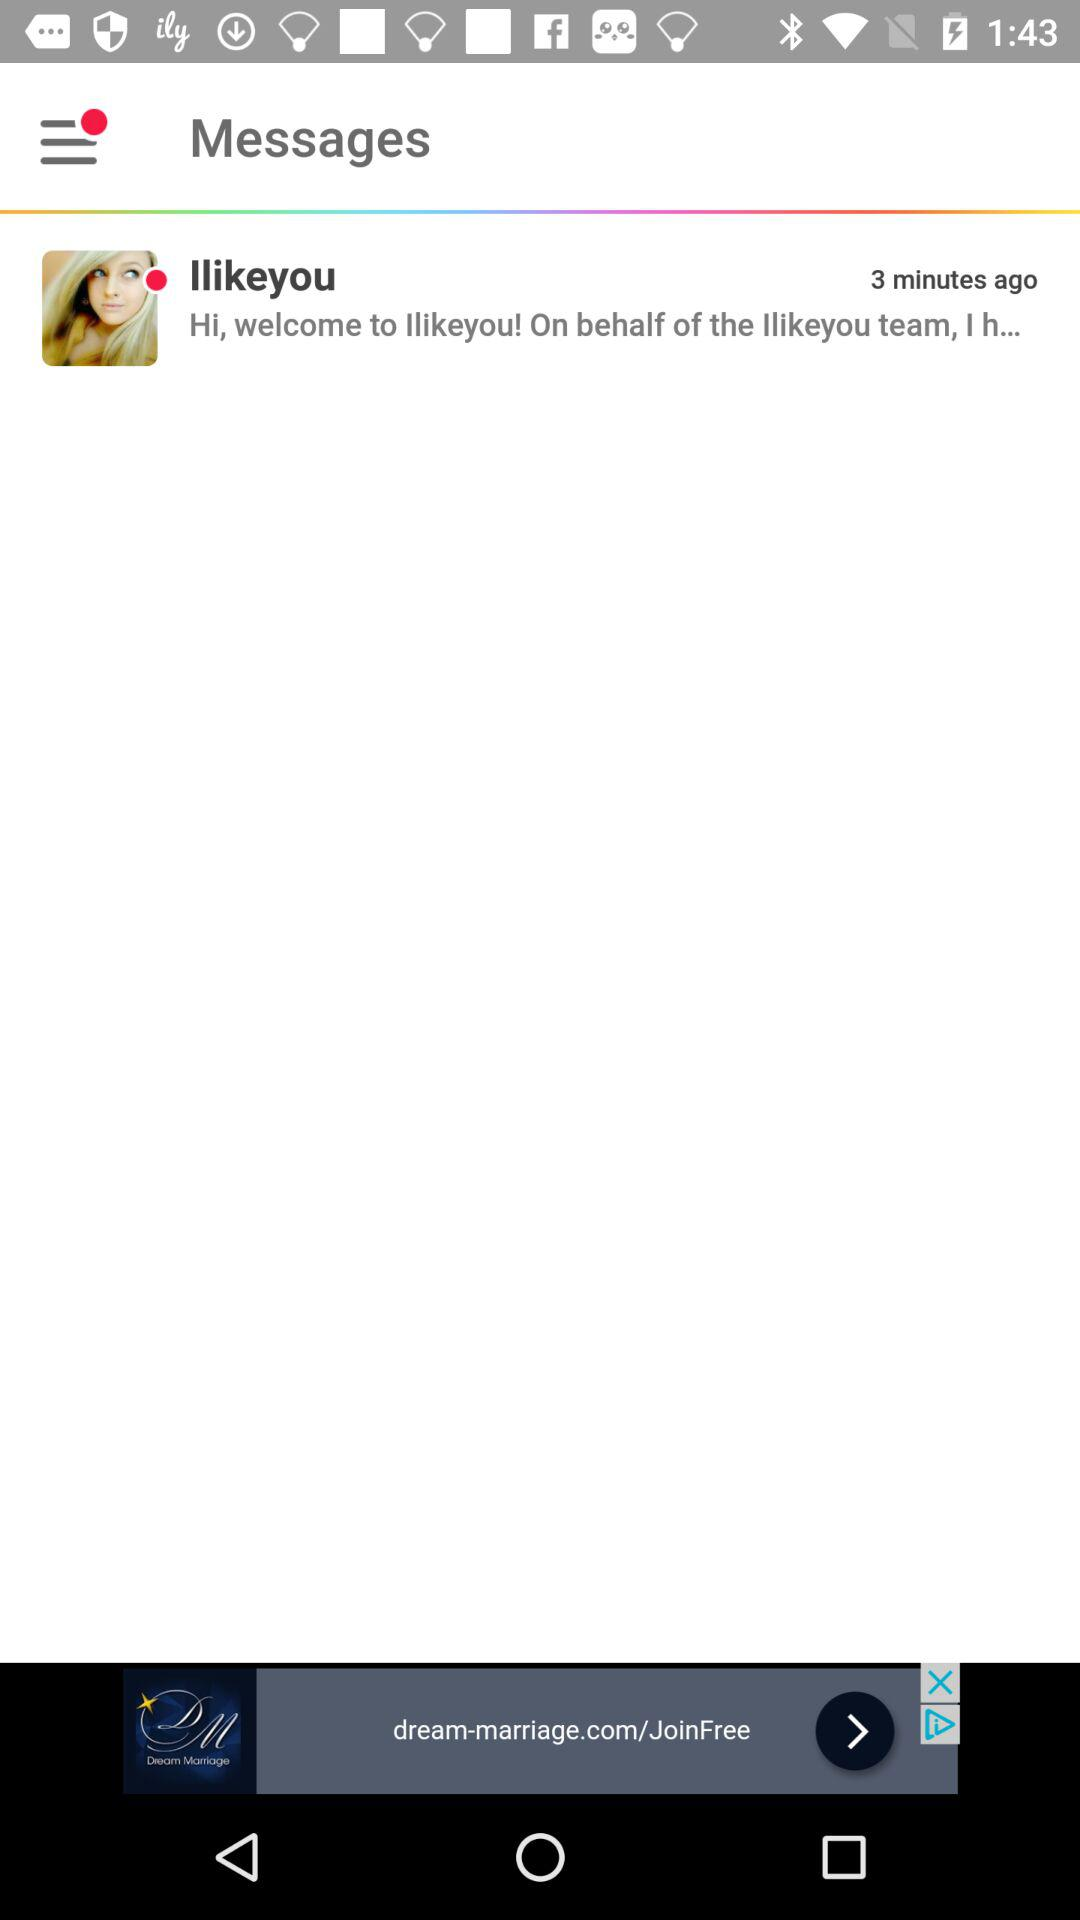Who was the messenger? The messenger was "Ilikeyou". 